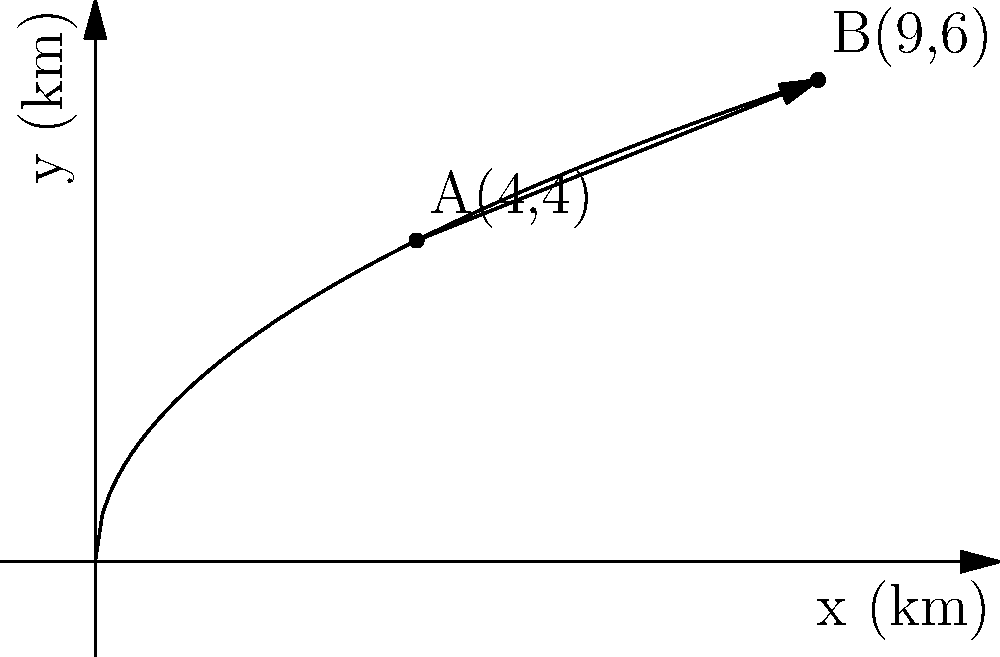A genetically modified organism (GMO) is released at point A(4,4) in an ecosystem. After a period of time, it spreads to point B(9,6). Assuming the spread follows the curve $y = 2\sqrt{x}$, calculate the magnitude of the vector representing the GMO's spread from A to B. How does this relate to the actual distance the GMO has traveled along the curve? To solve this problem, we'll follow these steps:

1) The vector representing the spread is $\vec{AB} = (9-4, 6-4) = (5, 2)$.

2) The magnitude of this vector is:
   $|\vec{AB}| = \sqrt{5^2 + 2^2} = \sqrt{29} \approx 5.39$ km

3) To find the actual distance traveled along the curve, we need to calculate the arc length from x=4 to x=9.

4) The formula for arc length is:
   $L = \int_{a}^{b} \sqrt{1 + [f'(x)]^2} dx$

5) For $y = 2\sqrt{x}$, $f'(x) = \frac{1}{\sqrt{x}}$

6) Substituting into the arc length formula:
   $L = \int_{4}^{9} \sqrt{1 + (\frac{1}{\sqrt{x}})^2} dx$

7) This integral is complex and typically solved numerically. The result is approximately 5.77 km.

8) The straight-line distance (5.39 km) is shorter than the curved path (5.77 km), as expected.

9) The ratio of actual distance to vector magnitude is about 1.07, indicating that the GMO traveled about 7% further than the straight-line distance suggests.

This analysis helps assess the spread rate and pattern of the GMO, which is crucial for evaluating its potential ecological impact and safety implications.
Answer: Vector magnitude: $\sqrt{29}$ km; Actual distance: ≈5.77 km; Ratio ≈1.07 